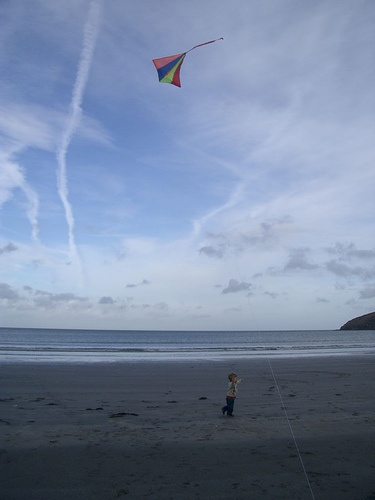Describe the objects in this image and their specific colors. I can see kite in gray, brown, navy, and green tones and people in gray and black tones in this image. 